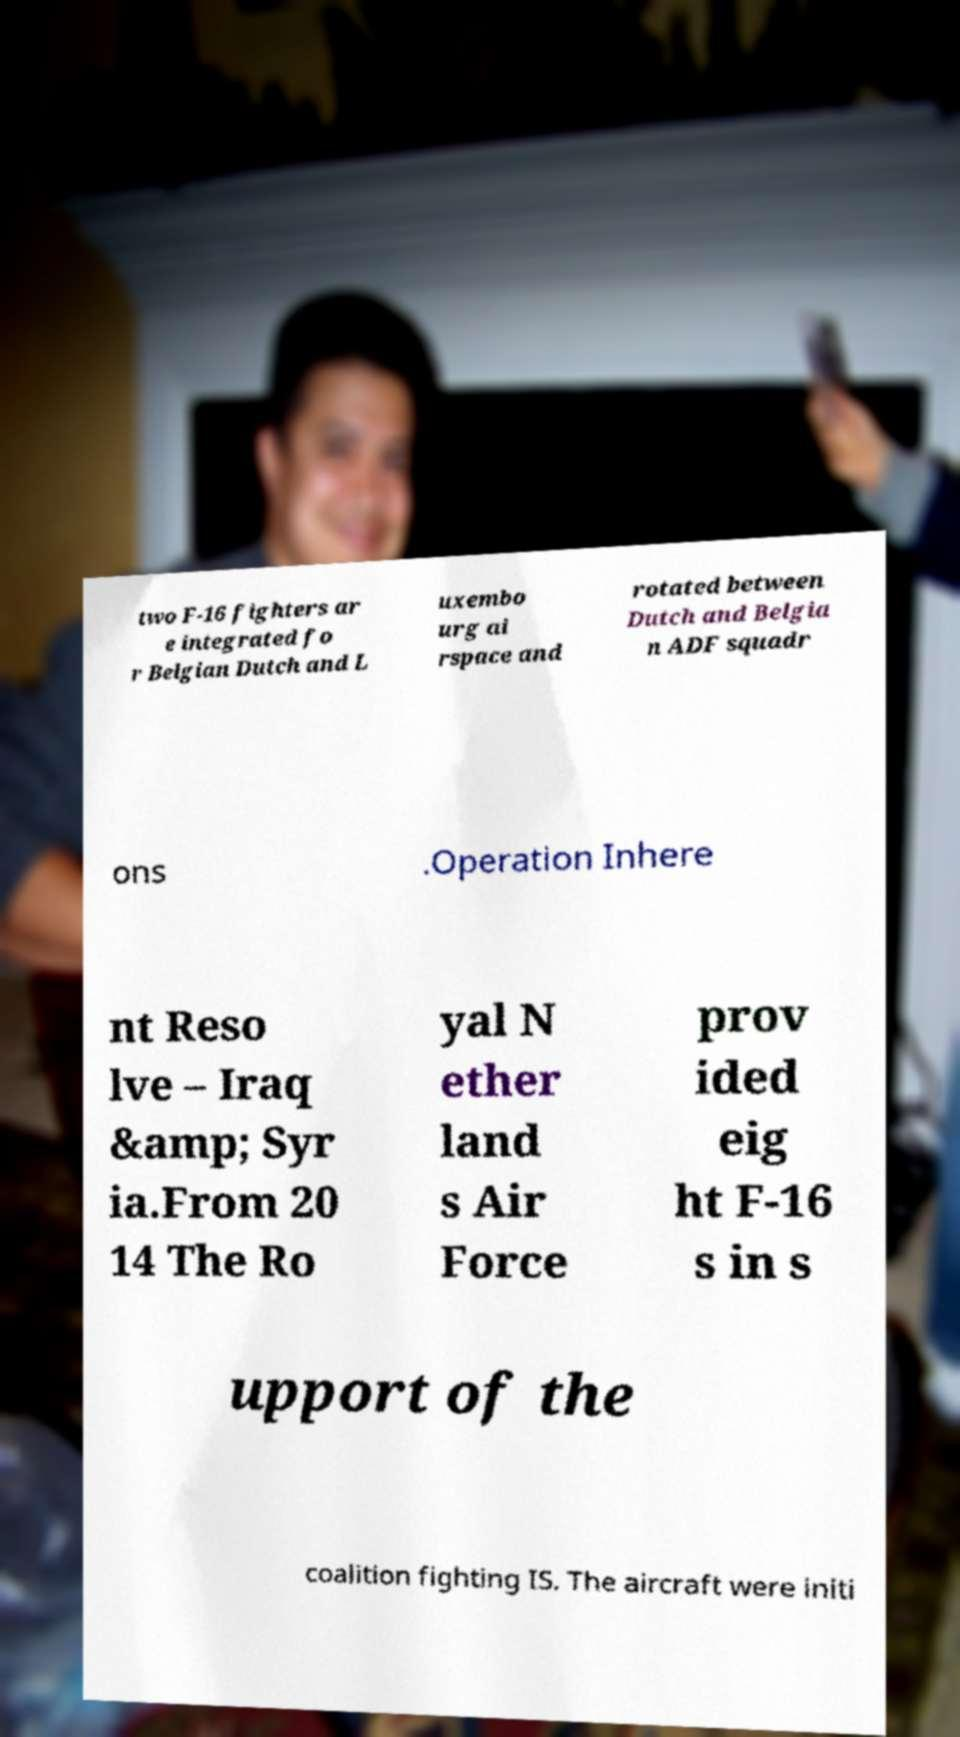Could you extract and type out the text from this image? two F-16 fighters ar e integrated fo r Belgian Dutch and L uxembo urg ai rspace and rotated between Dutch and Belgia n ADF squadr ons .Operation Inhere nt Reso lve – Iraq &amp; Syr ia.From 20 14 The Ro yal N ether land s Air Force prov ided eig ht F-16 s in s upport of the coalition fighting IS. The aircraft were initi 